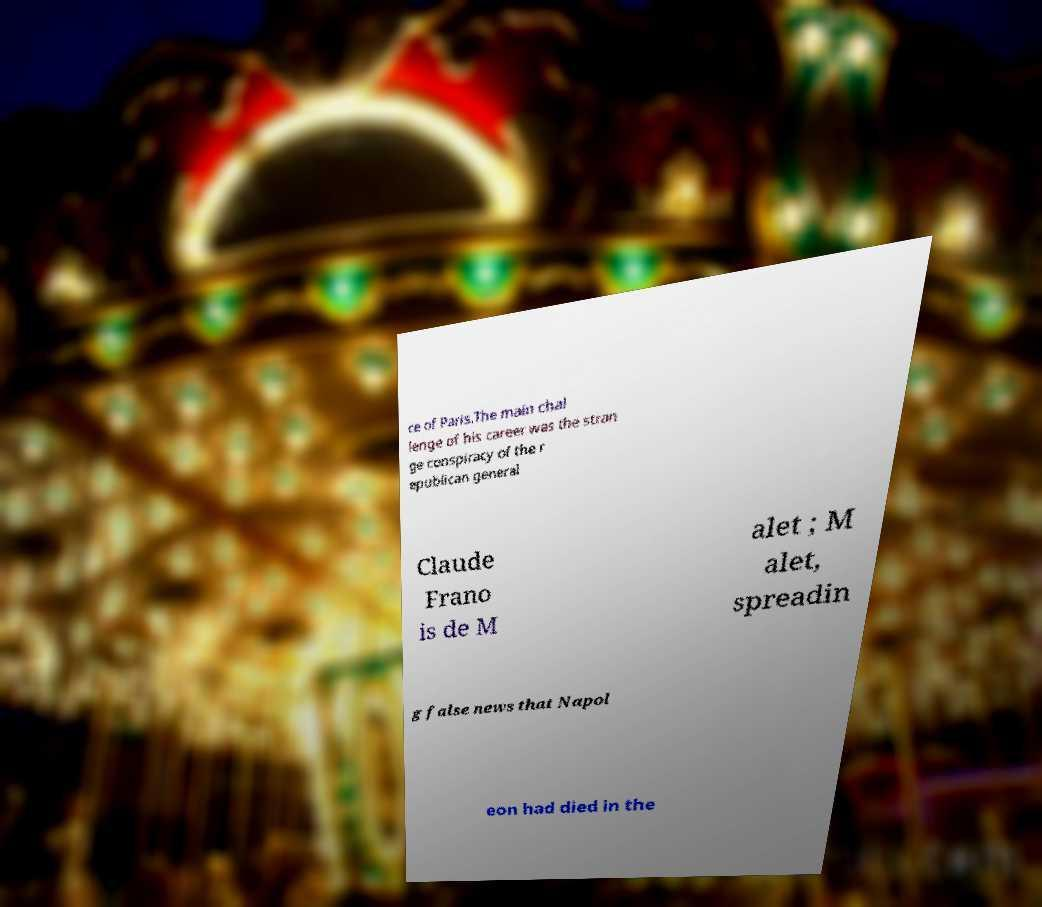Please identify and transcribe the text found in this image. ce of Paris.The main chal lenge of his career was the stran ge conspiracy of the r epublican general Claude Frano is de M alet ; M alet, spreadin g false news that Napol eon had died in the 